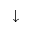<formula> <loc_0><loc_0><loc_500><loc_500>\downarrow</formula> 